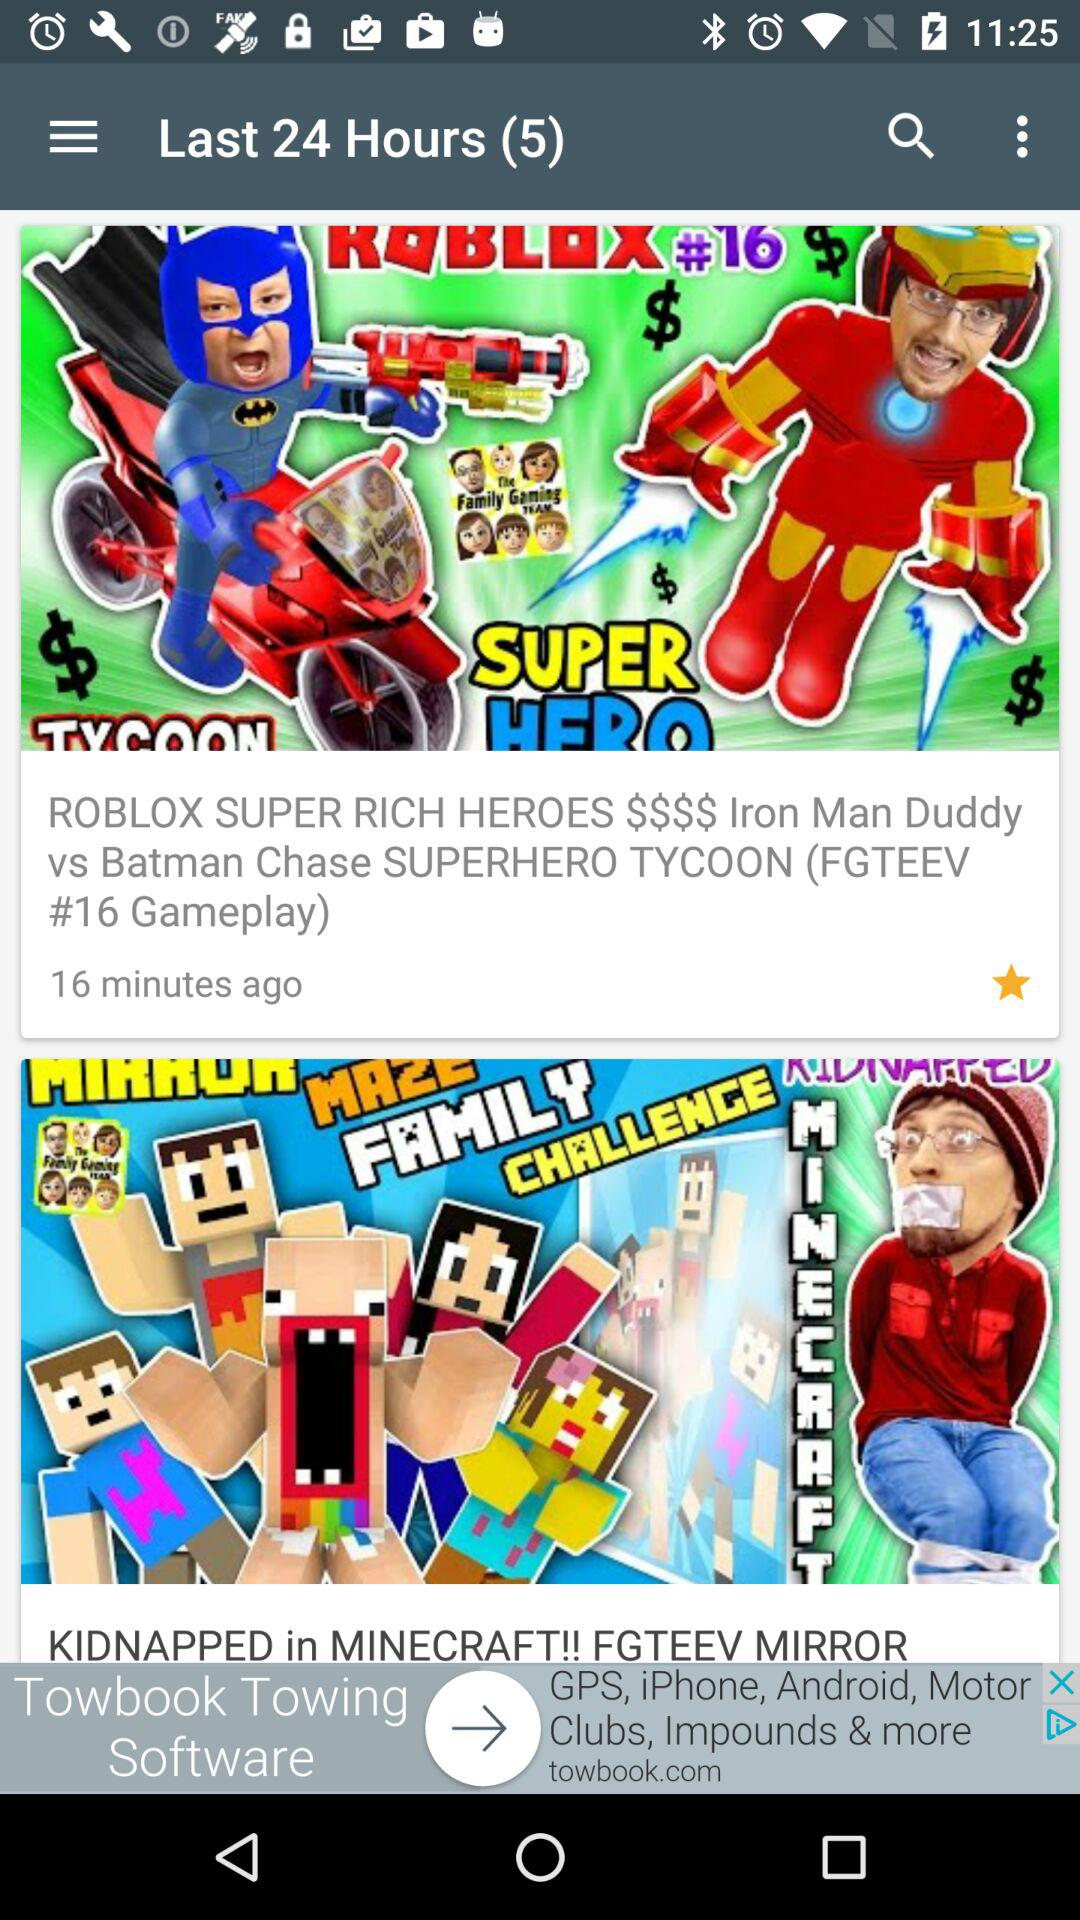How many new notifications have there been in the last 24 hours? There have been 5 new notifications in the last 24 hours. 